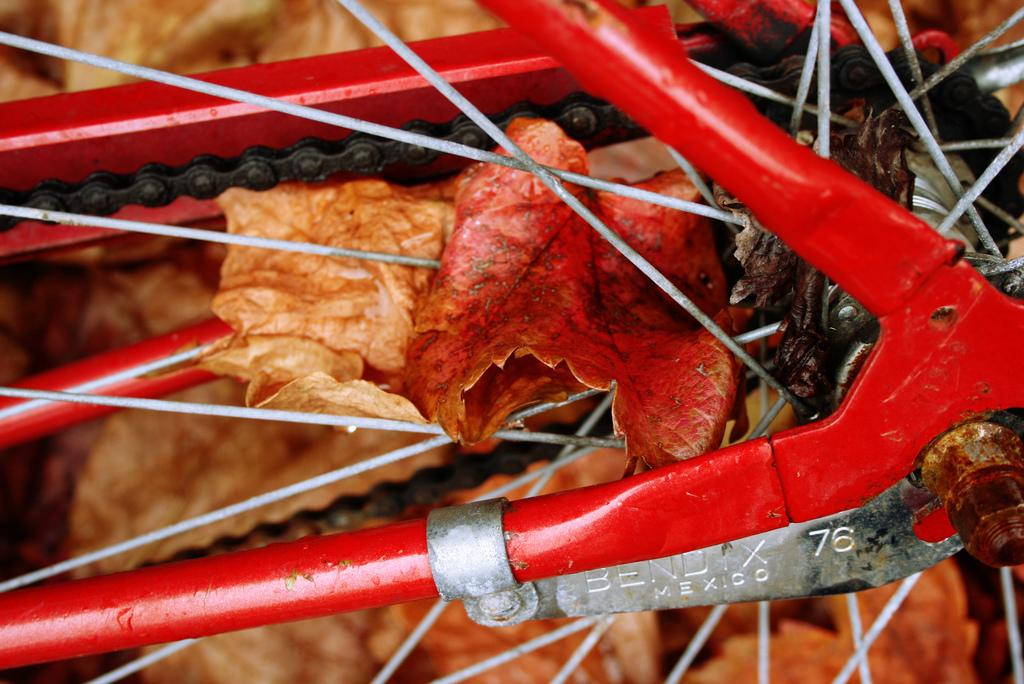What type of cycle part is shown in the image? The image shows a cycle part with spokes, a fork, and a chain. What is the purpose of the spokes in the cycle part? The spokes provide support and help to distribute the weight of the rider. What is the function of the fork in the cycle part? The fork connects the front wheel to the frame of the cycle and allows for steering. What is the role of the chain in the cycle part? The chain transfers power from the pedals to the rear wheel, enabling the cycle to move. What additional detail can be observed on the spokes? Leaves are visible on the spokes in the image. How does the stitch on the cycle part affect its performance? There is no stitch present on the cycle part in the image, so its performance is not affected by any stitch. 